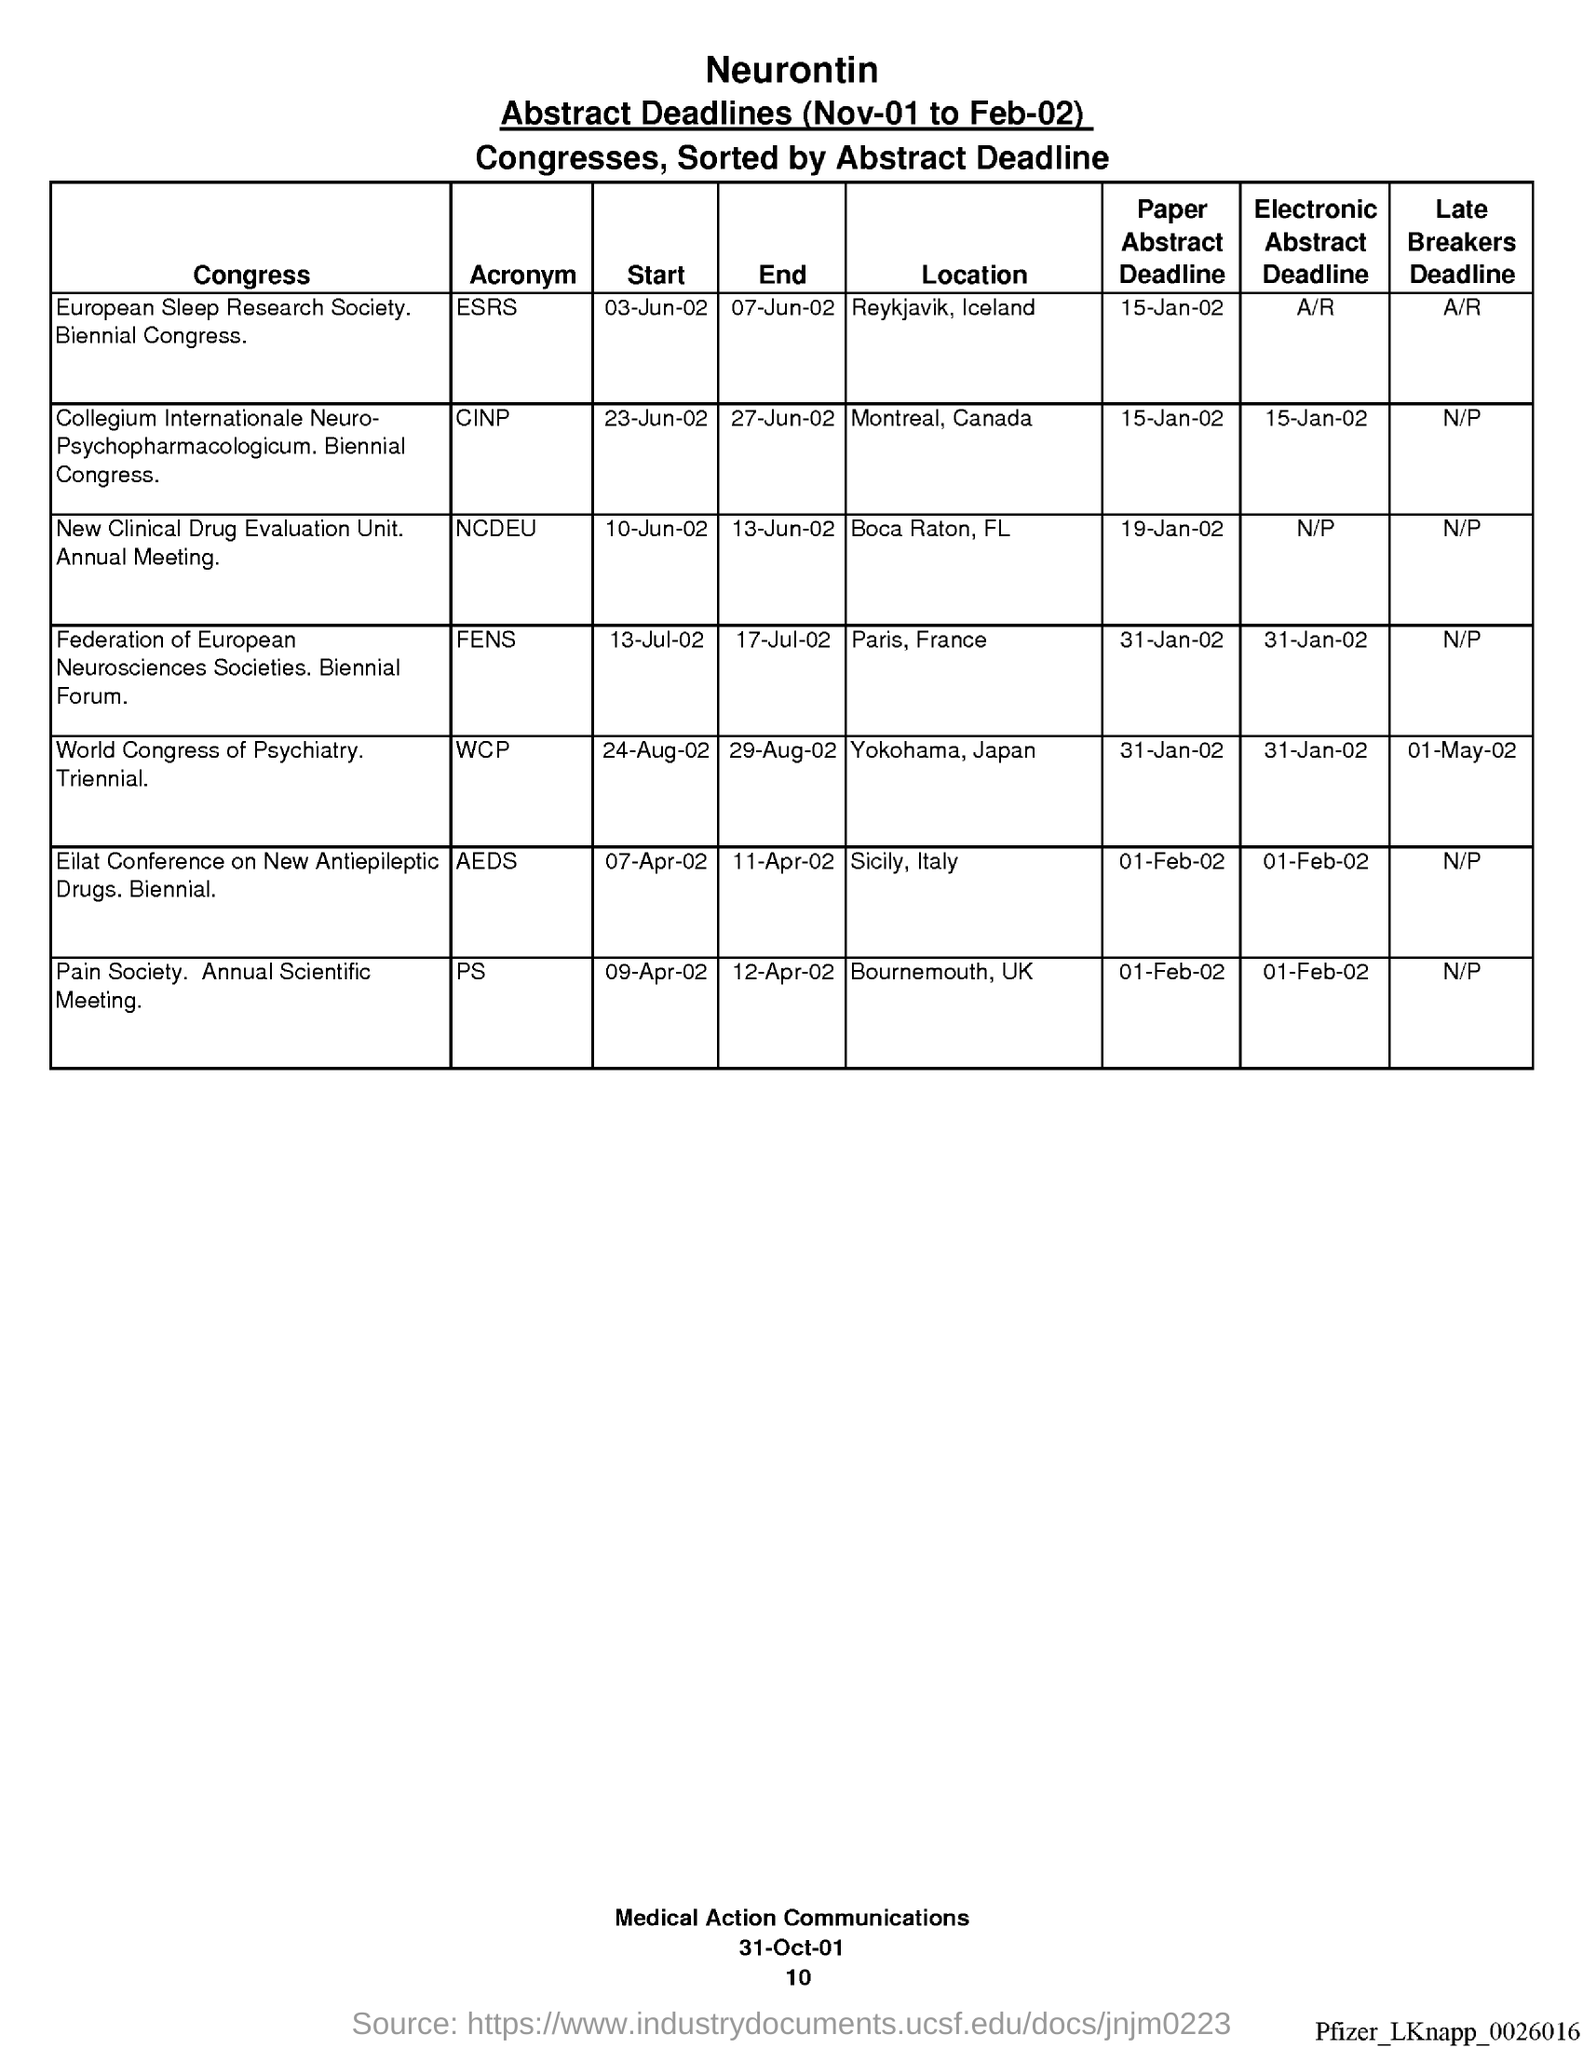Indicate a few pertinent items in this graphic. The location of PS is Bournemouth, UK. ESRS is located in Reykjavik, Iceland. The paper abstract deadline for NCDEU is January 19, 2002. The location for the World Cup Profit tournament is Yokohama, Japan. The location of AEDS is in Sicily, Italy. 